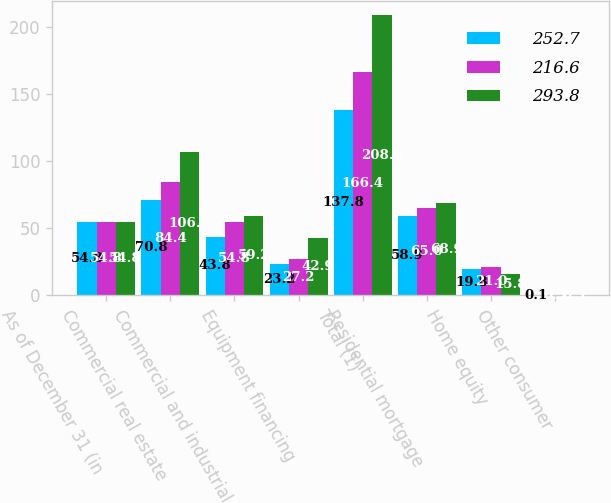Convert chart. <chart><loc_0><loc_0><loc_500><loc_500><stacked_bar_chart><ecel><fcel>As of December 31 (in<fcel>Commercial real estate<fcel>Commercial and industrial<fcel>Equipment financing<fcel>Total (1)<fcel>Residential mortgage<fcel>Home equity<fcel>Other consumer<nl><fcel>252.7<fcel>54.8<fcel>70.8<fcel>43.8<fcel>23.2<fcel>137.8<fcel>58.9<fcel>19.8<fcel>0.1<nl><fcel>216.6<fcel>54.8<fcel>84.4<fcel>54.8<fcel>27.2<fcel>166.4<fcel>65<fcel>21<fcel>0.3<nl><fcel>293.8<fcel>54.8<fcel>106.7<fcel>59.2<fcel>42.9<fcel>208.8<fcel>68.9<fcel>15.8<fcel>0.3<nl></chart> 